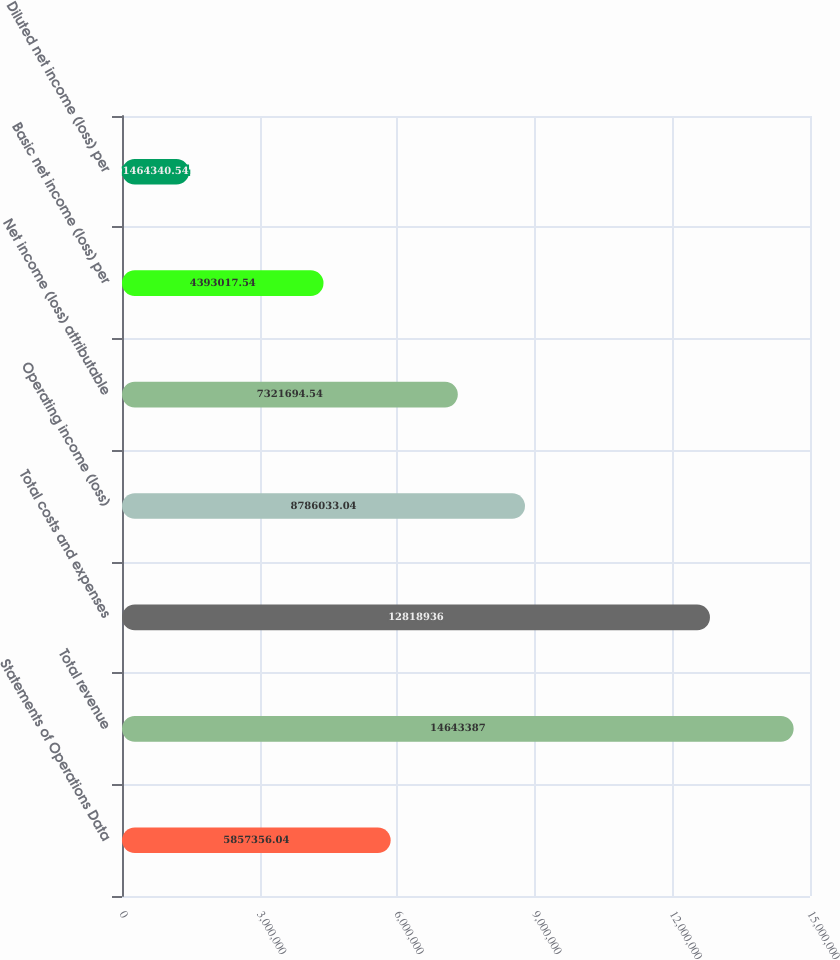<chart> <loc_0><loc_0><loc_500><loc_500><bar_chart><fcel>Statements of Operations Data<fcel>Total revenue<fcel>Total costs and expenses<fcel>Operating income (loss)<fcel>Net income (loss) attributable<fcel>Basic net income (loss) per<fcel>Diluted net income (loss) per<nl><fcel>5.85736e+06<fcel>1.46434e+07<fcel>1.28189e+07<fcel>8.78603e+06<fcel>7.32169e+06<fcel>4.39302e+06<fcel>1.46434e+06<nl></chart> 